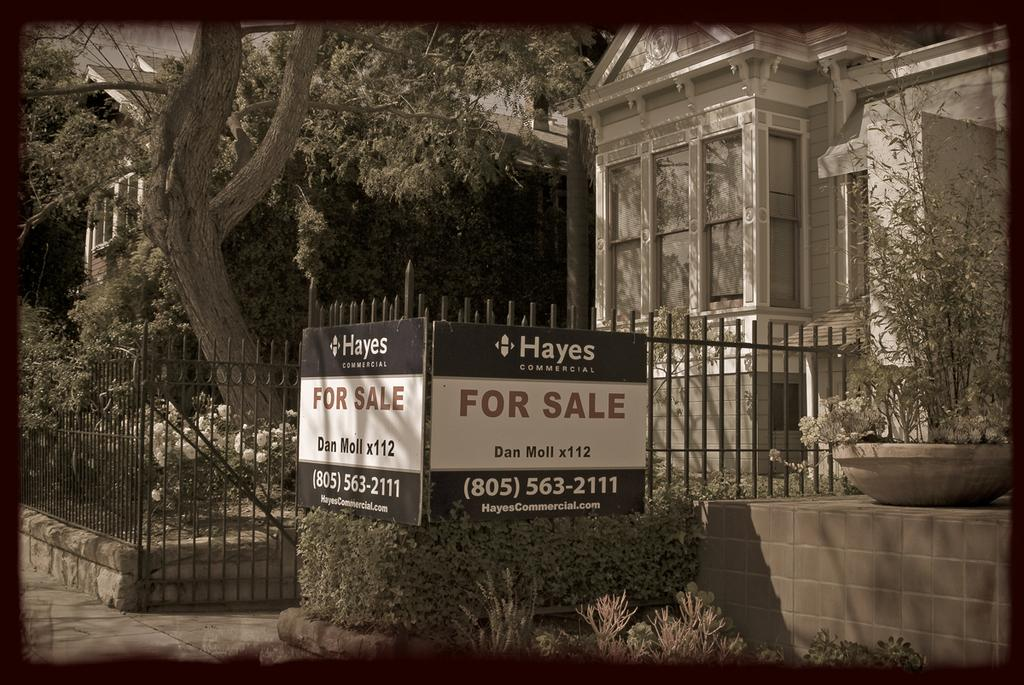What objects are present in the image that are made of wood or similar material? There are boards in the image. What type of plants can be seen in the image? There are houseplants in the image. What type of barrier is visible in the image? There is a fence in the image. What type of structures are visible in the image? There are buildings in the image. What type of vegetation is visible in the image? There are trees in the image. How is the image presented? The image appears to be a photo frame. Can you hear the support of the trees in the image? The support of the trees cannot be heard in the image, as it is a visual medium and does not convey sound. 